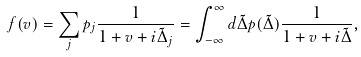Convert formula to latex. <formula><loc_0><loc_0><loc_500><loc_500>f ( v ) = \sum _ { j } p _ { j } \frac { 1 } { 1 + v + i \tilde { \Delta } _ { j } } = \int _ { - \infty } ^ { \infty } d \tilde { \Delta } p ( \tilde { \Delta } ) \frac { 1 } { 1 + v + i \tilde { \Delta } } ,</formula> 